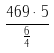Convert formula to latex. <formula><loc_0><loc_0><loc_500><loc_500>\frac { 4 6 9 \cdot 5 } { \frac { 6 } { 4 } }</formula> 